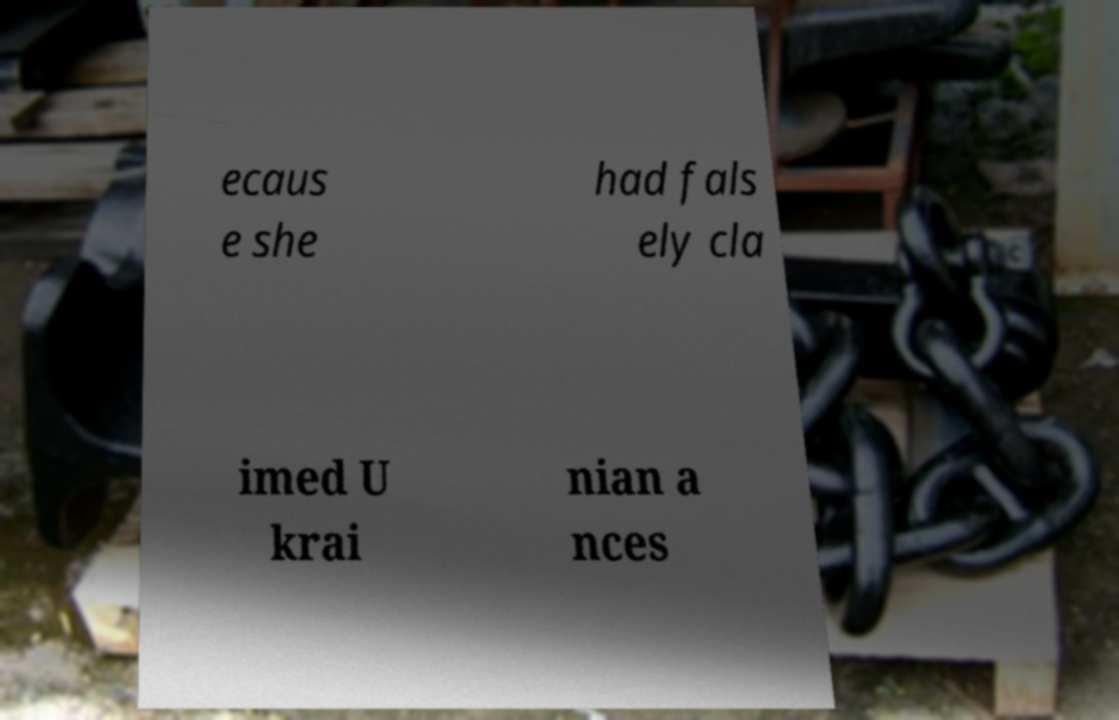Please read and relay the text visible in this image. What does it say? ecaus e she had fals ely cla imed U krai nian a nces 